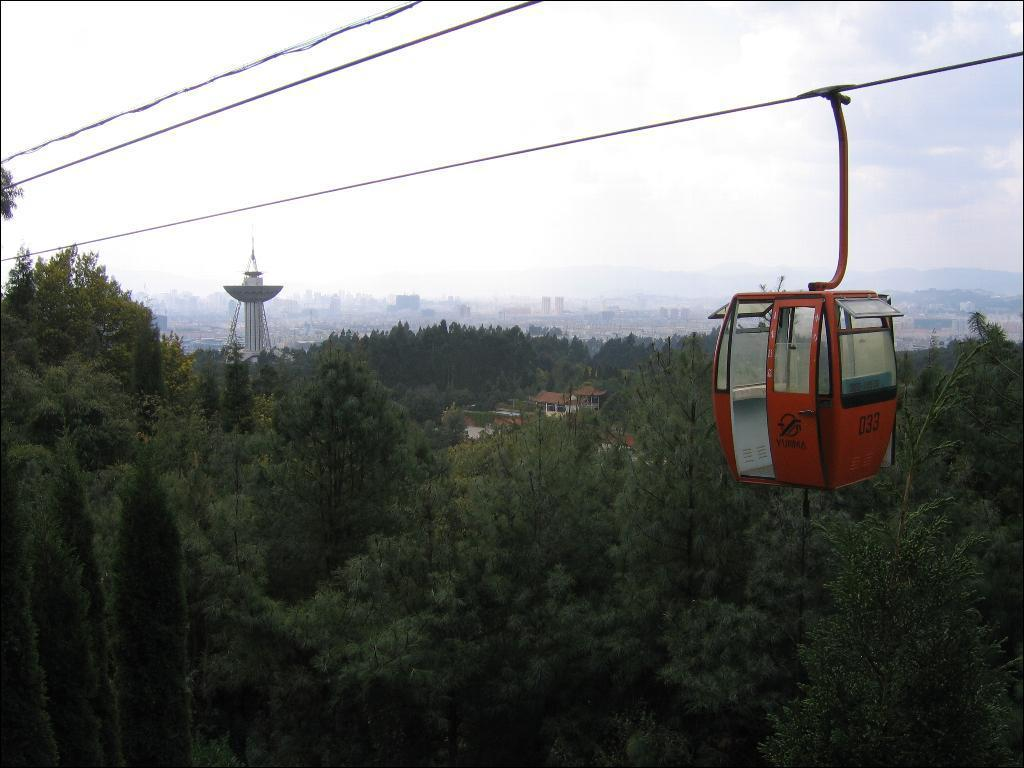What is the main subject of the image? The main subject of the image is a cable car moving in the foreground. What can be seen in the background of the image? In the background of the image, there are trees, buildings, a tower, and the sky. What type of location is depicted in the image? The image depicts a city. Can you describe the sky in the image? The sky is visible in the background of the image, and there is a cloud present. What type of angle is the cable car taking in the image? The image does not provide information about the angle of the cable car. What is the range of the cable car in the image? The image does not provide information about the range of the cable car. 